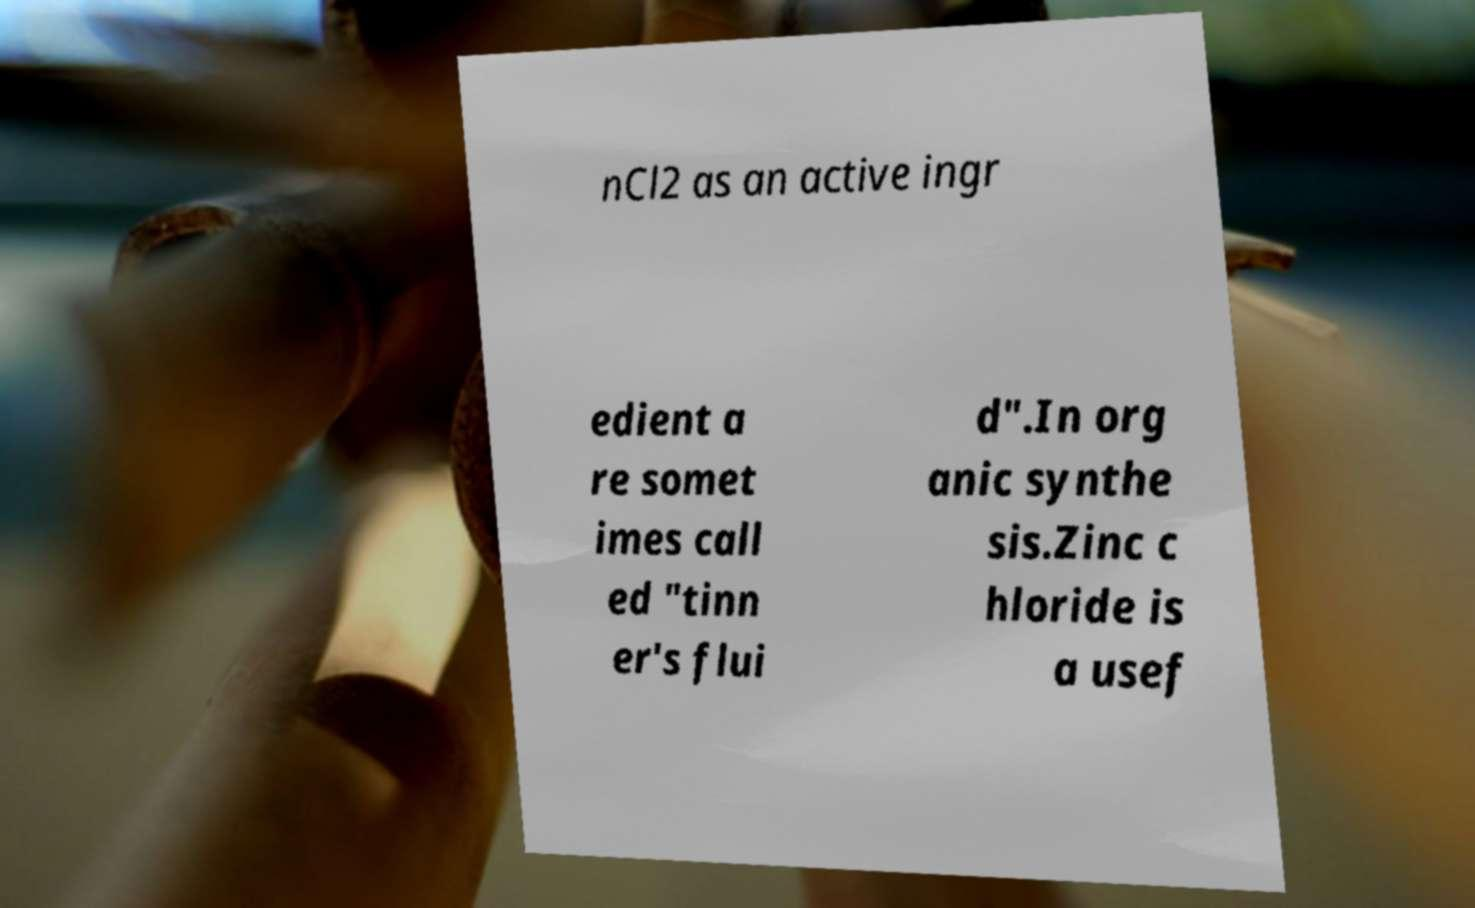Can you accurately transcribe the text from the provided image for me? nCl2 as an active ingr edient a re somet imes call ed "tinn er's flui d".In org anic synthe sis.Zinc c hloride is a usef 